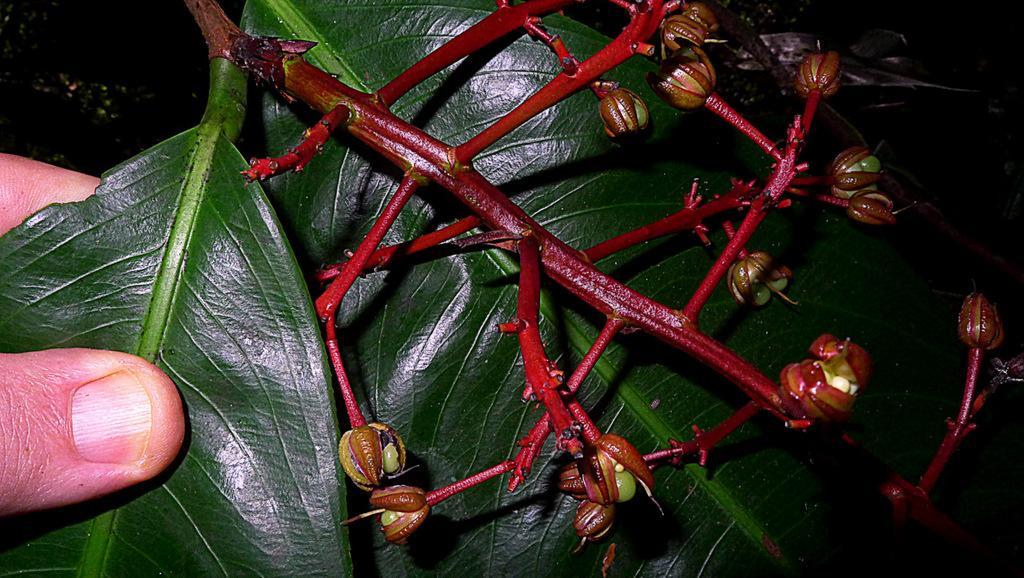Could you give a brief overview of what you see in this image? In this image I can see a flowering portion of a plant with some capsule like buds with seeds inside and some leaves. 